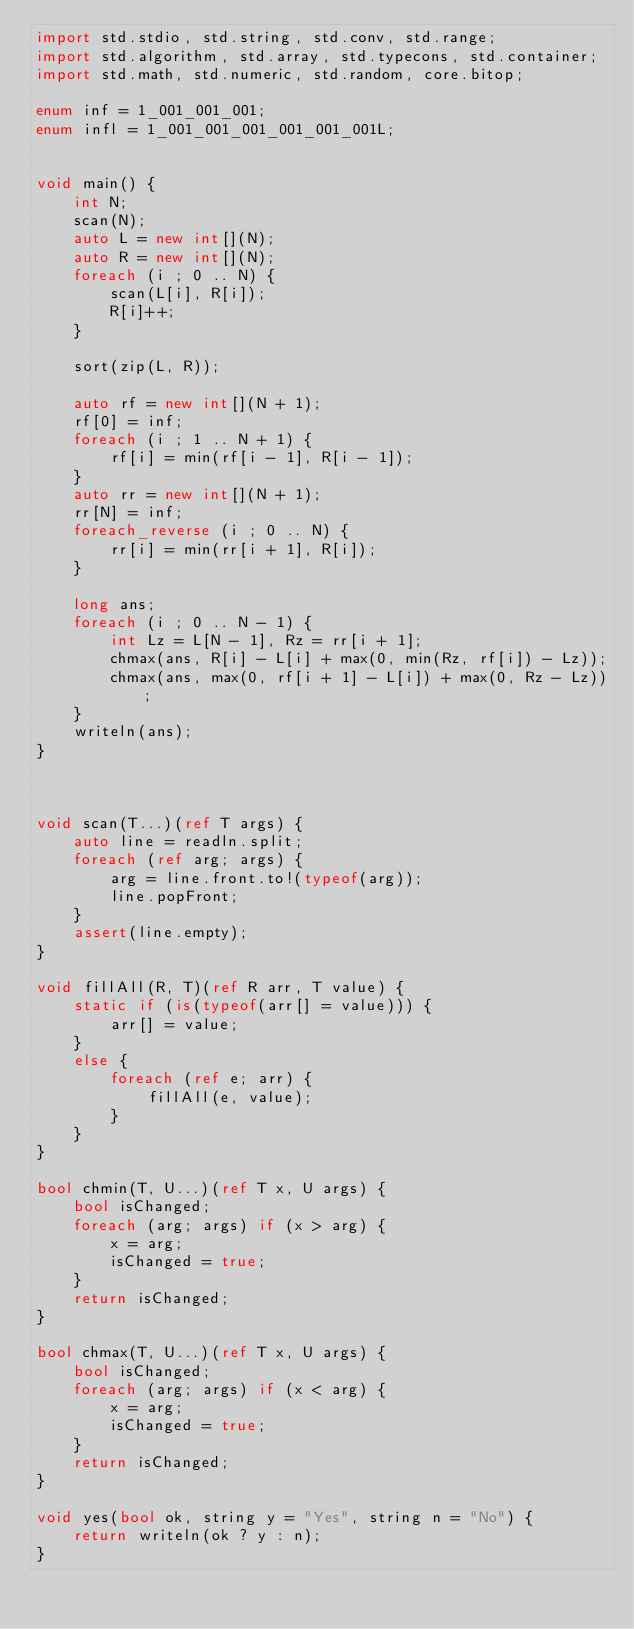<code> <loc_0><loc_0><loc_500><loc_500><_D_>import std.stdio, std.string, std.conv, std.range;
import std.algorithm, std.array, std.typecons, std.container;
import std.math, std.numeric, std.random, core.bitop;

enum inf = 1_001_001_001;
enum infl = 1_001_001_001_001_001_001L;


void main() {
    int N;
    scan(N);
    auto L = new int[](N);
    auto R = new int[](N);
    foreach (i ; 0 .. N) {
        scan(L[i], R[i]);
        R[i]++;
    }

    sort(zip(L, R));

    auto rf = new int[](N + 1);
    rf[0] = inf;
    foreach (i ; 1 .. N + 1) {
        rf[i] = min(rf[i - 1], R[i - 1]);
    }
    auto rr = new int[](N + 1);
    rr[N] = inf;
    foreach_reverse (i ; 0 .. N) {
        rr[i] = min(rr[i + 1], R[i]);
    }

    long ans;
    foreach (i ; 0 .. N - 1) {
        int Lz = L[N - 1], Rz = rr[i + 1];
        chmax(ans, R[i] - L[i] + max(0, min(Rz, rf[i]) - Lz));
        chmax(ans, max(0, rf[i + 1] - L[i]) + max(0, Rz - Lz));
    }
    writeln(ans);
}



void scan(T...)(ref T args) {
    auto line = readln.split;
    foreach (ref arg; args) {
        arg = line.front.to!(typeof(arg));
        line.popFront;
    }
    assert(line.empty);
}

void fillAll(R, T)(ref R arr, T value) {
    static if (is(typeof(arr[] = value))) {
        arr[] = value;
    }
    else {
        foreach (ref e; arr) {
            fillAll(e, value);
        }
    }
}

bool chmin(T, U...)(ref T x, U args) {
    bool isChanged;
    foreach (arg; args) if (x > arg) {
        x = arg;
        isChanged = true;
    }
    return isChanged;
}

bool chmax(T, U...)(ref T x, U args) {
    bool isChanged;
    foreach (arg; args) if (x < arg) {
        x = arg;
        isChanged = true;
    }
    return isChanged;
}

void yes(bool ok, string y = "Yes", string n = "No") {
    return writeln(ok ? y : n);
}
</code> 